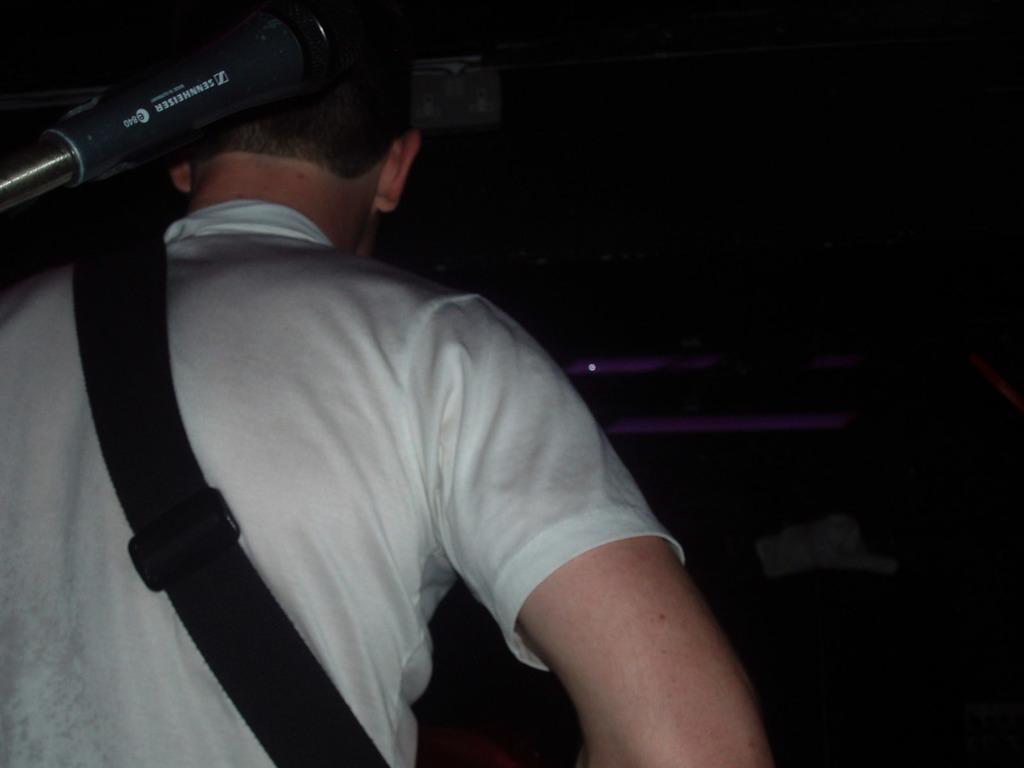Can you describe this image briefly? In this image we can see a person wearing a white color t-shirt and bag. The background of the image is not clear. 